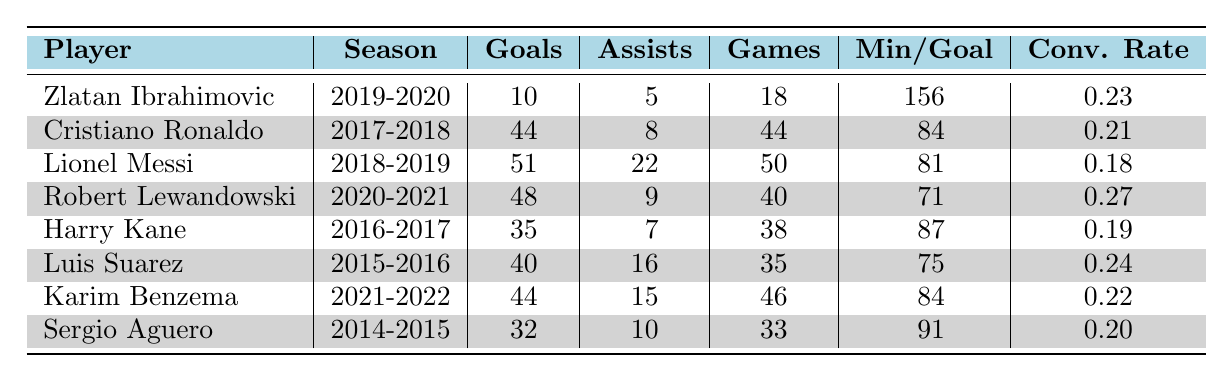What was the highest number of goals scored by a player in a single season? Looking at the table, Lionel Messi scored 51 goals during the 2018-2019 season, which is the highest figure among all players listed.
Answer: 51 Which player had the best conversion rate in the table? Robert Lewandowski achieved a conversion rate of 0.27 during the 2020-2021 season, which is the highest conversion rate recorded in the table.
Answer: 0.27 How many assists did Harry Kane provide in the 2016-2017 season? Referring to the table, Harry Kane recorded 7 assists during the 2016-2017 season.
Answer: 7 Who scored more goals, Karim Benzema or Cristiano Ronaldo? Karim Benzema scored 44 goals in the 2021-2022 season, while Cristiano Ronaldo scored 44 in 2017-2018. They both have the same number of goals but spent a different number of games. Therefore, they are tied in this category.
Answer: Equal What is the average number of goals scored by the players listed in the table? To find the average, sum the goals scored: (10 + 44 + 51 + 48 + 35 + 40 + 44 + 32) = 364. There are 8 players, so the average is 364/8 = 45.5.
Answer: 45.5 Did Luis Suarez have a higher goals-to-games ratio than Harry Kane? Luis Suarez scored 40 goals in 35 games, giving a goals-to-games ratio of 40/35 = 1.14. Harry Kane scored 35 goals in 38 games, giving a ratio of 35/38 ≈ 0.92. Therefore, Suarez had a higher goals-to-games ratio.
Answer: Yes What is the total number of assists provided by all players in the table? Summing the assists: (5 + 8 + 22 + 9 + 7 + 16 + 15 + 10) = 92.
Answer: 92 Which player needs the most minutes per goal scored? Zlatan Ibrahimovic needed 156 minutes per goal in the 2019-2020 season, which is the highest of all players listed in the table.
Answer: 156 If we consider only the seasons listed, who played the fewest games? Zlatan Ibrahimovic played 18 games in the 2019-2020 season, which is the fewest among all players in the table.
Answer: 18 What is the difference in goals scored between Messi and Lewandowski? Lionel Messi scored 51 goals, while Robert Lewandowski scored 48 goals. The difference is 51 - 48 = 3 goals.
Answer: 3 Who was the second-highest goalscorer in the table? Cristiano Ronaldo with 44 goals in 2017-2018 and Karim Benzema with 44 goals in 2021-2022 both tie as the second-highest goalscorers.
Answer: Cristiano Ronaldo and Karim Benzema 